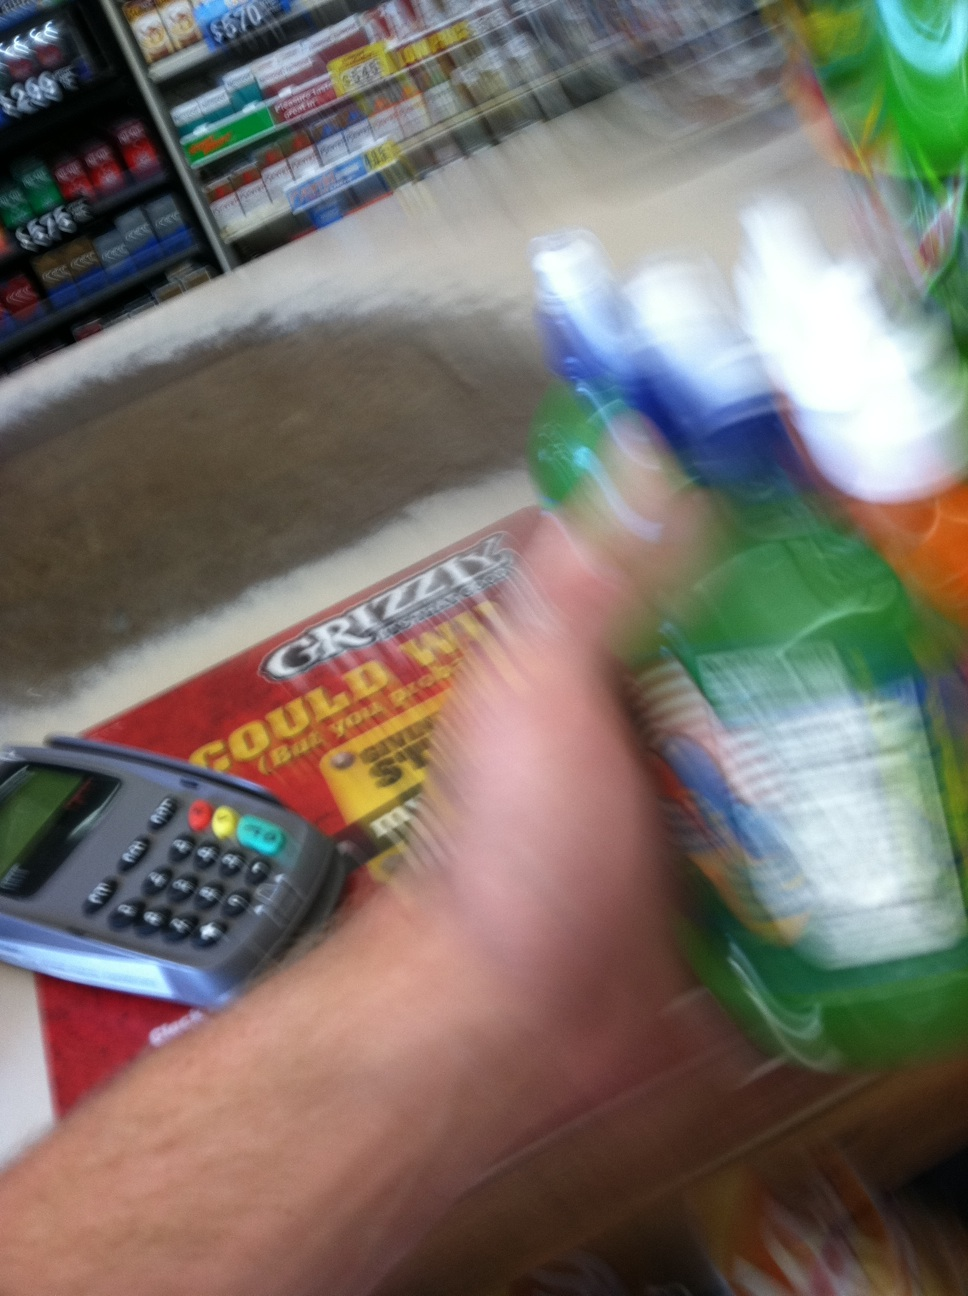What is this? This is a blurry image taken at a checkout counter in a store. The photo captures a moment where someone is either about to pay for or has just selected a variety of bottled drinks. The image includes a glimpse of a card payment machine and promotional materials on the counter. 